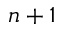Convert formula to latex. <formula><loc_0><loc_0><loc_500><loc_500>n + 1</formula> 